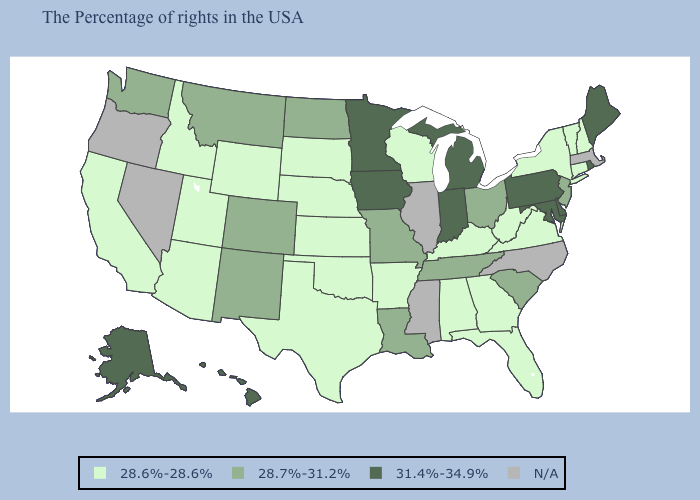Name the states that have a value in the range 31.4%-34.9%?
Keep it brief. Maine, Rhode Island, Delaware, Maryland, Pennsylvania, Michigan, Indiana, Minnesota, Iowa, Alaska, Hawaii. Among the states that border Louisiana , which have the highest value?
Quick response, please. Arkansas, Texas. What is the value of Tennessee?
Write a very short answer. 28.7%-31.2%. Name the states that have a value in the range 28.7%-31.2%?
Give a very brief answer. New Jersey, South Carolina, Ohio, Tennessee, Louisiana, Missouri, North Dakota, Colorado, New Mexico, Montana, Washington. What is the value of Idaho?
Short answer required. 28.6%-28.6%. Does Maine have the highest value in the Northeast?
Quick response, please. Yes. Which states have the lowest value in the Northeast?
Keep it brief. New Hampshire, Vermont, Connecticut, New York. How many symbols are there in the legend?
Be succinct. 4. Does Florida have the lowest value in the USA?
Quick response, please. Yes. Name the states that have a value in the range N/A?
Quick response, please. Massachusetts, North Carolina, Illinois, Mississippi, Nevada, Oregon. What is the lowest value in states that border Delaware?
Keep it brief. 28.7%-31.2%. Among the states that border New Hampshire , which have the highest value?
Write a very short answer. Maine. Name the states that have a value in the range 31.4%-34.9%?
Write a very short answer. Maine, Rhode Island, Delaware, Maryland, Pennsylvania, Michigan, Indiana, Minnesota, Iowa, Alaska, Hawaii. What is the value of New York?
Write a very short answer. 28.6%-28.6%. Name the states that have a value in the range 31.4%-34.9%?
Be succinct. Maine, Rhode Island, Delaware, Maryland, Pennsylvania, Michigan, Indiana, Minnesota, Iowa, Alaska, Hawaii. 